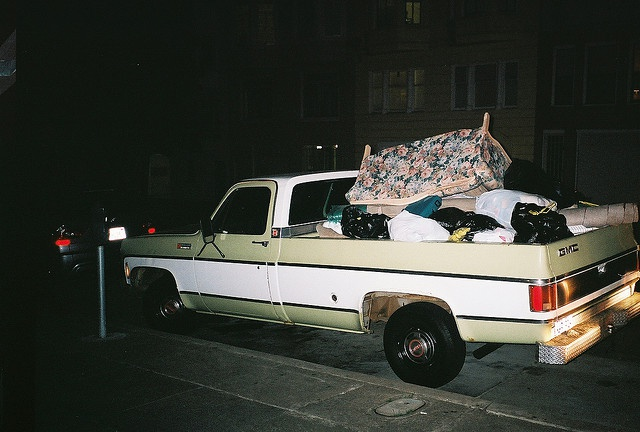Describe the objects in this image and their specific colors. I can see truck in black, lightgray, gray, and darkgray tones, couch in black, darkgray, gray, tan, and lightgray tones, car in black, white, gray, and purple tones, backpack in black, gray, beige, and darkgray tones, and parking meter in black, gray, teal, and maroon tones in this image. 